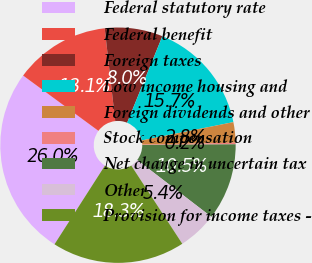Convert chart to OTSL. <chart><loc_0><loc_0><loc_500><loc_500><pie_chart><fcel>Federal statutory rate<fcel>Federal benefit<fcel>Foreign taxes<fcel>Low income housing and<fcel>Foreign dividends and other<fcel>Stock compensation<fcel>Net change in uncertain tax<fcel>Other<fcel>Provision for income taxes -<nl><fcel>26.01%<fcel>13.12%<fcel>7.96%<fcel>15.7%<fcel>2.8%<fcel>0.22%<fcel>10.54%<fcel>5.38%<fcel>18.27%<nl></chart> 